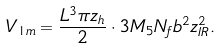<formula> <loc_0><loc_0><loc_500><loc_500>V _ { 1 m } = \frac { L ^ { 3 } \pi z _ { h } } { 2 } \cdot 3 M _ { 5 } N _ { f } b ^ { 2 } z ^ { 2 } _ { I R } .</formula> 